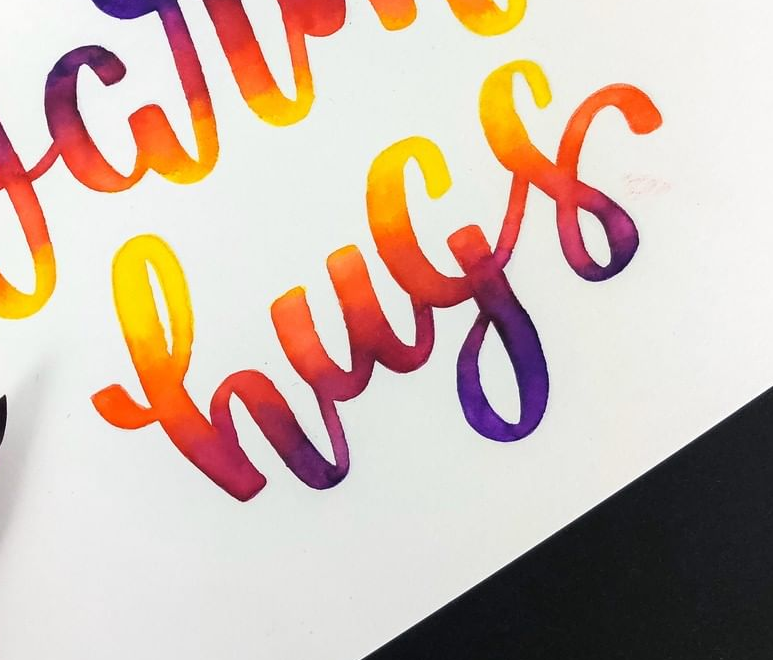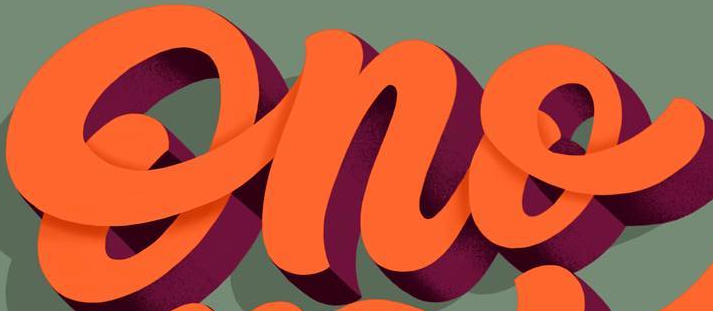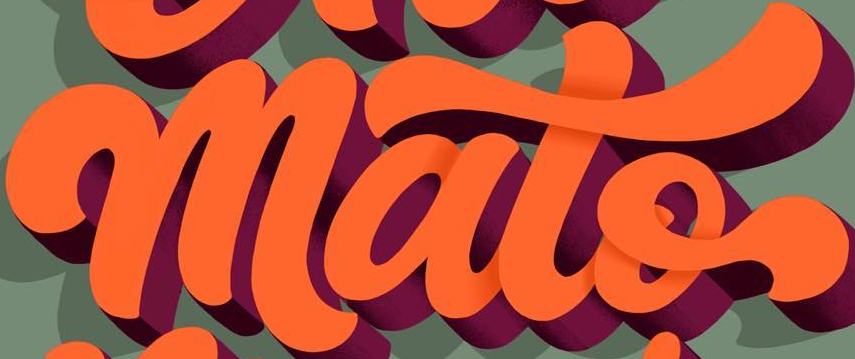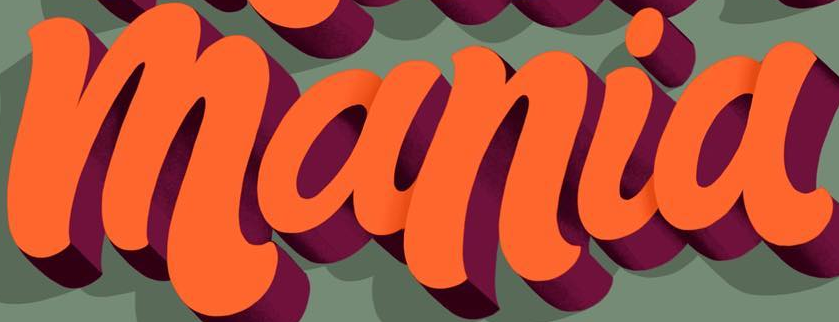Read the text from these images in sequence, separated by a semicolon. hugs; Ono; mato; mania 